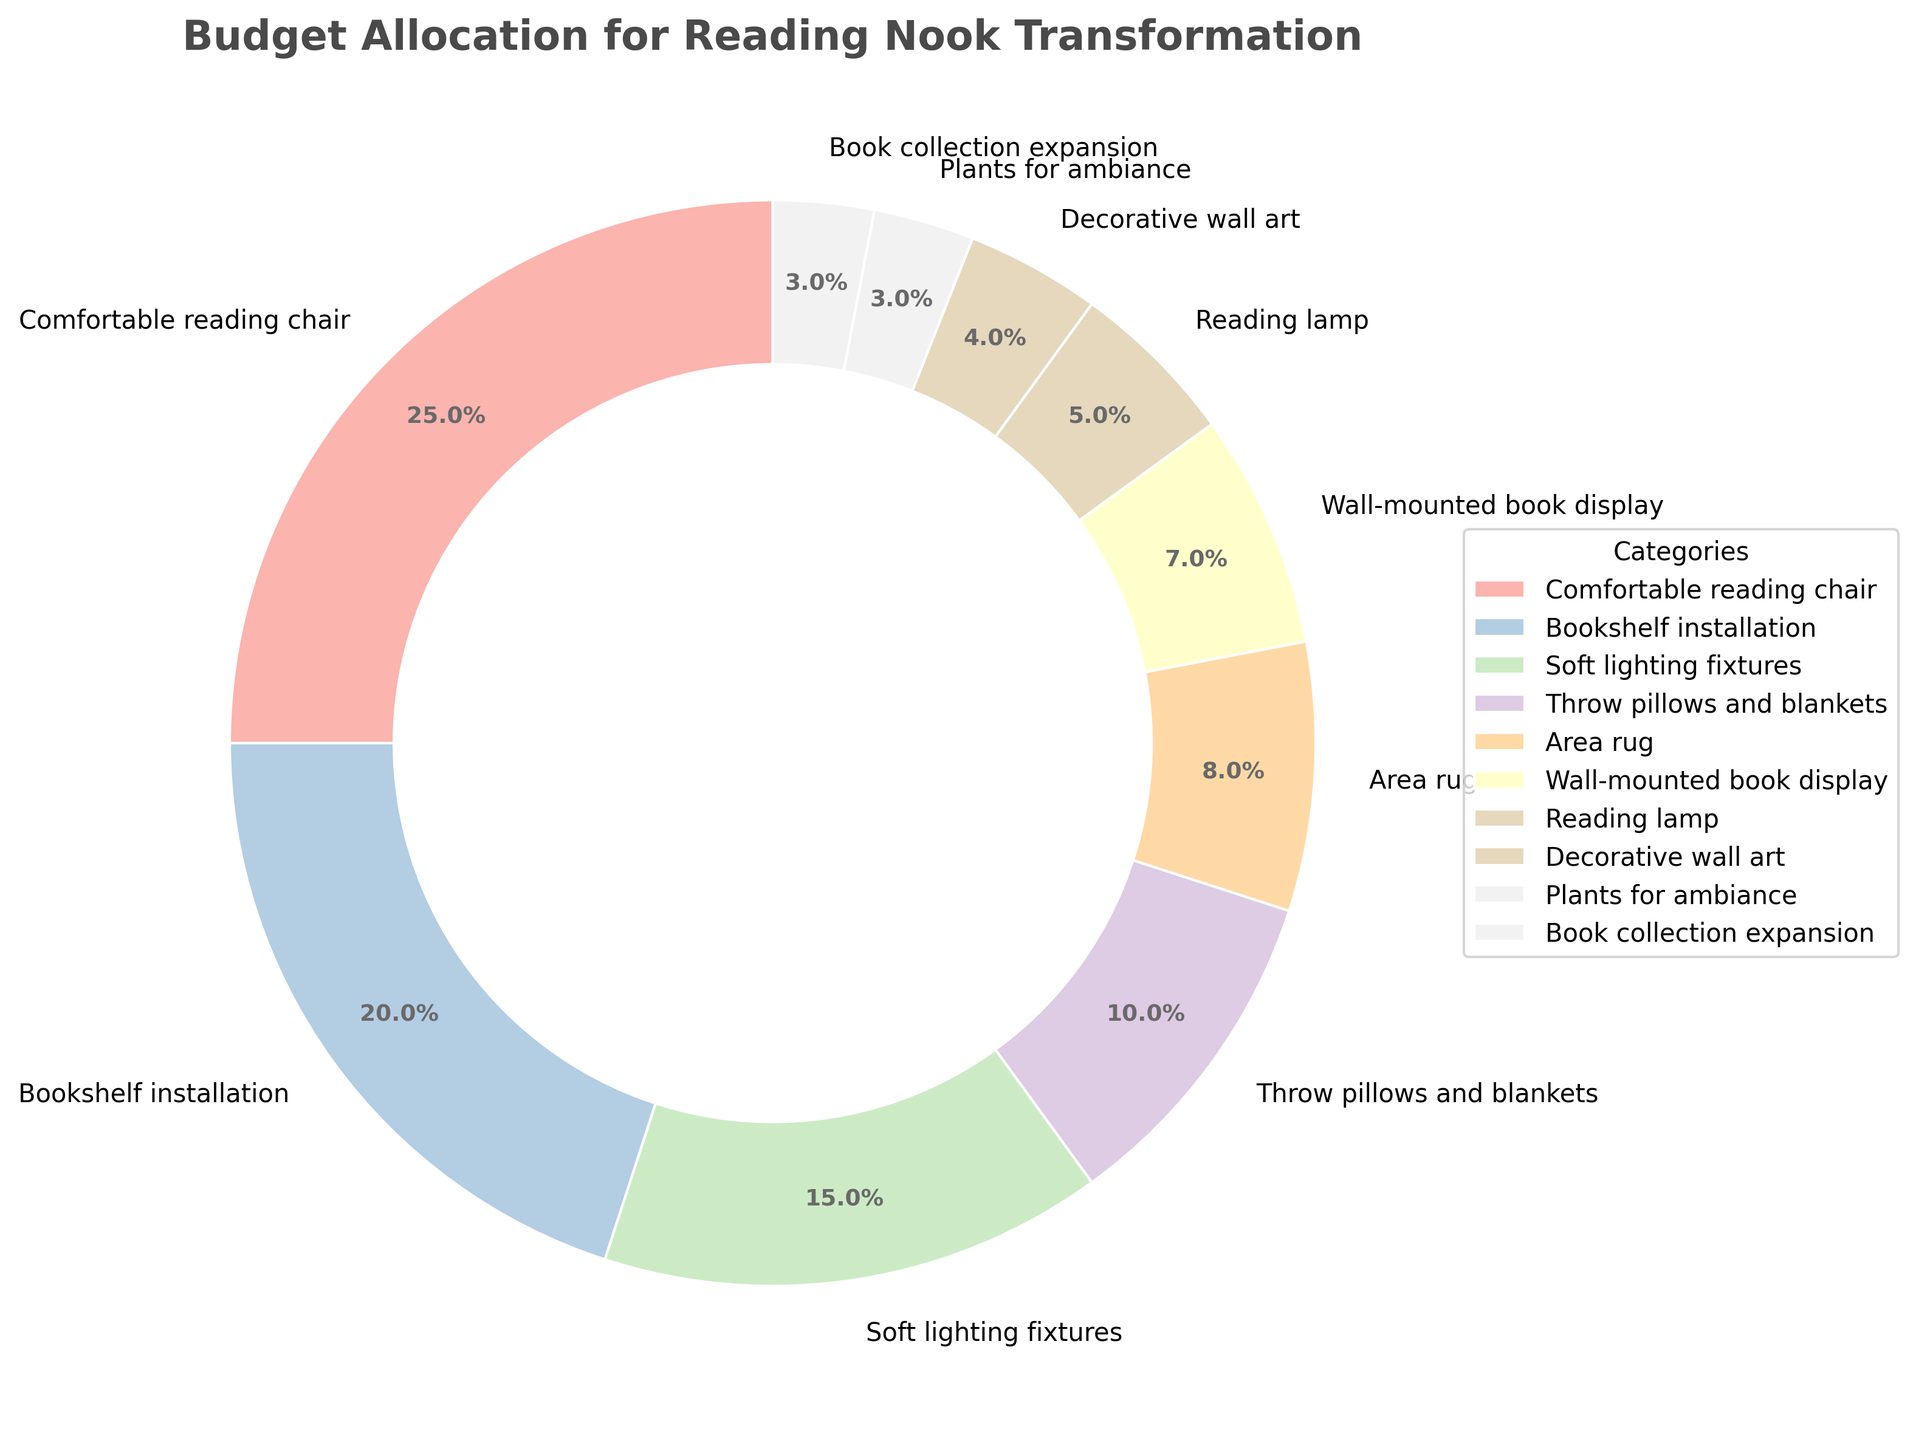What percentage of the budget is allocated to the combination of the reading lamp and decorative wall art? Add the percentages of the reading lamp (5%) and decorative wall art (4%), so 5% + 4% = 9%.
Answer: 9% Which category receives more budget, the comfortable reading chair or the bookshelf installation? Compare the percentages: the comfortable reading chair has 25%, while the bookshelf installation has 20%. 25% is greater than 20%, so the comfortable reading chair receives more budget.
Answer: Comfortable reading chair How much budget is allocated in total to the throw pillows and blankets, area rug, and plants for ambiance? Sum the percentages: throw pillows and blankets (10%), area rug (8%), and plants for ambiance (3%), so 10% + 8% + 3% = 21%.
Answer: 21% Which category has the smallest allocation in the budget? Look for the smallest percentage in the chart. The book collection expansion and plants for ambiance both share the lowest percentage, 3%.
Answer: Book collection expansion and plants for ambiance How does the budget for soft lighting fixtures compare to that for an area rug? Compare the percentages: soft lighting fixtures have 15%, and area rug has 8%. 15% is greater than 8%, so soft lighting fixtures have a higher budget allocation.
Answer: Soft lighting fixtures Is the budget for throw pillows and blankets higher than that for wall-mounted book display? Compare the percentages: throw pillows and blankets have 10%, while the wall-mounted book display has 7%. 10% is higher than 7%, so the budget for throw pillows and blankets is higher.
Answer: Yes Calculate the collective budget percentage for the categories that contribute to ambiance (throw pillows and blankets, area rug, plants for ambiance). Adding the percentages for throw pillows and blankets (10%), area rug (8%), and plants for ambiance (3%) gives 10% + 8% + 3% = 21%.
Answer: 21% Between the categories with the highest allocation and the lowest allocation, what is the difference in their budget percentages? Subtract the smallest percentage (3% for book collection expansion or plants for ambiance) from the largest percentage (25% for comfortable reading chair), so 25% - 3% = 22%.
Answer: 22% Is the budget for the bookshelf installation greater than the sum of the budgets for the reading lamp and decorative wall art? Calculate the sum of the budgets for the reading lamp (5%) and decorative wall art (4%): 5% + 4% = 9%. Then compare it to the budget for bookshelf installation (20%). 20% is greater than 9%.
Answer: Yes Which two categories together make up half of the total budget? The two largest categories are the comfortable reading chair (25%) and bookshelf installation (20%). Adding these gives 25% + 20% = 45%, which is less than half. Adding the next largest category, soft lighting fixtures (15%), gives 25% + 20% + 15% = 60%, which exceeds half. Therefore, no two categories together sum up to exactly half of the total budget.
Answer: None 